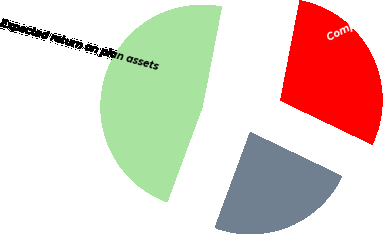<chart> <loc_0><loc_0><loc_500><loc_500><pie_chart><fcel>Discount rate<fcel>Expected return on plan assets<fcel>Compensation increase rate<nl><fcel>23.52%<fcel>47.39%<fcel>29.09%<nl></chart> 